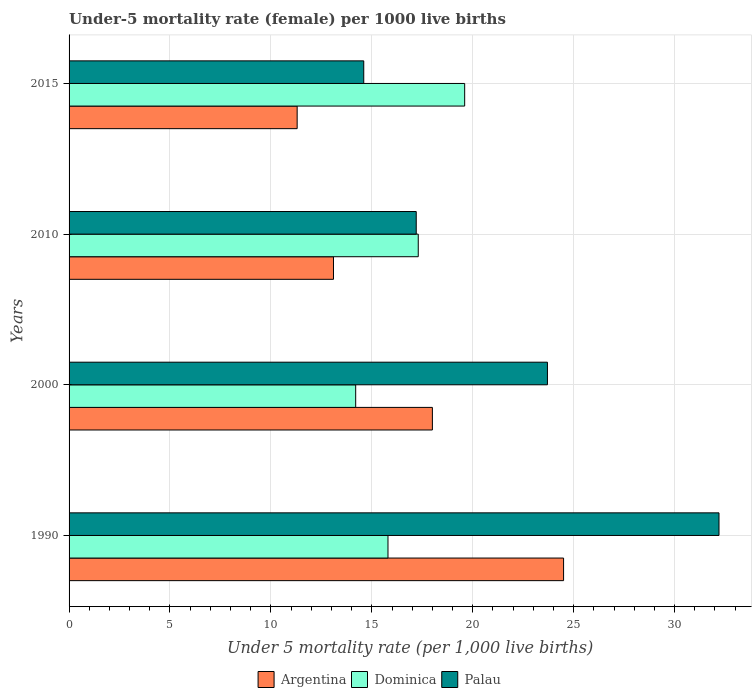How many different coloured bars are there?
Provide a short and direct response. 3. How many groups of bars are there?
Make the answer very short. 4. Are the number of bars on each tick of the Y-axis equal?
Ensure brevity in your answer.  Yes. How many bars are there on the 1st tick from the top?
Ensure brevity in your answer.  3. Across all years, what is the maximum under-five mortality rate in Palau?
Your response must be concise. 32.2. In which year was the under-five mortality rate in Palau maximum?
Make the answer very short. 1990. In which year was the under-five mortality rate in Argentina minimum?
Your answer should be very brief. 2015. What is the total under-five mortality rate in Palau in the graph?
Make the answer very short. 87.7. What is the difference between the under-five mortality rate in Dominica in 1990 and that in 2000?
Give a very brief answer. 1.6. What is the difference between the under-five mortality rate in Argentina in 1990 and the under-five mortality rate in Palau in 2010?
Give a very brief answer. 7.3. What is the average under-five mortality rate in Argentina per year?
Ensure brevity in your answer.  16.73. In the year 2000, what is the difference between the under-five mortality rate in Palau and under-five mortality rate in Argentina?
Provide a short and direct response. 5.7. What is the ratio of the under-five mortality rate in Argentina in 1990 to that in 2015?
Your answer should be compact. 2.17. What is the difference between the highest and the second highest under-five mortality rate in Dominica?
Offer a very short reply. 2.3. In how many years, is the under-five mortality rate in Argentina greater than the average under-five mortality rate in Argentina taken over all years?
Provide a succinct answer. 2. What does the 1st bar from the top in 2010 represents?
Make the answer very short. Palau. Is it the case that in every year, the sum of the under-five mortality rate in Palau and under-five mortality rate in Argentina is greater than the under-five mortality rate in Dominica?
Your answer should be compact. Yes. How many years are there in the graph?
Offer a terse response. 4. Where does the legend appear in the graph?
Give a very brief answer. Bottom center. What is the title of the graph?
Provide a succinct answer. Under-5 mortality rate (female) per 1000 live births. Does "Puerto Rico" appear as one of the legend labels in the graph?
Ensure brevity in your answer.  No. What is the label or title of the X-axis?
Your answer should be compact. Under 5 mortality rate (per 1,0 live births). What is the label or title of the Y-axis?
Your response must be concise. Years. What is the Under 5 mortality rate (per 1,000 live births) of Dominica in 1990?
Your response must be concise. 15.8. What is the Under 5 mortality rate (per 1,000 live births) in Palau in 1990?
Make the answer very short. 32.2. What is the Under 5 mortality rate (per 1,000 live births) of Argentina in 2000?
Keep it short and to the point. 18. What is the Under 5 mortality rate (per 1,000 live births) of Palau in 2000?
Provide a short and direct response. 23.7. What is the Under 5 mortality rate (per 1,000 live births) in Argentina in 2010?
Give a very brief answer. 13.1. What is the Under 5 mortality rate (per 1,000 live births) of Palau in 2010?
Offer a very short reply. 17.2. What is the Under 5 mortality rate (per 1,000 live births) of Dominica in 2015?
Provide a succinct answer. 19.6. What is the Under 5 mortality rate (per 1,000 live births) of Palau in 2015?
Give a very brief answer. 14.6. Across all years, what is the maximum Under 5 mortality rate (per 1,000 live births) in Argentina?
Make the answer very short. 24.5. Across all years, what is the maximum Under 5 mortality rate (per 1,000 live births) of Dominica?
Give a very brief answer. 19.6. Across all years, what is the maximum Under 5 mortality rate (per 1,000 live births) in Palau?
Your response must be concise. 32.2. Across all years, what is the minimum Under 5 mortality rate (per 1,000 live births) in Palau?
Give a very brief answer. 14.6. What is the total Under 5 mortality rate (per 1,000 live births) in Argentina in the graph?
Your answer should be very brief. 66.9. What is the total Under 5 mortality rate (per 1,000 live births) of Dominica in the graph?
Provide a succinct answer. 66.9. What is the total Under 5 mortality rate (per 1,000 live births) in Palau in the graph?
Your response must be concise. 87.7. What is the difference between the Under 5 mortality rate (per 1,000 live births) in Dominica in 1990 and that in 2000?
Ensure brevity in your answer.  1.6. What is the difference between the Under 5 mortality rate (per 1,000 live births) in Argentina in 1990 and that in 2010?
Offer a very short reply. 11.4. What is the difference between the Under 5 mortality rate (per 1,000 live births) of Dominica in 1990 and that in 2010?
Offer a very short reply. -1.5. What is the difference between the Under 5 mortality rate (per 1,000 live births) in Dominica in 2000 and that in 2010?
Provide a short and direct response. -3.1. What is the difference between the Under 5 mortality rate (per 1,000 live births) of Palau in 2000 and that in 2010?
Your response must be concise. 6.5. What is the difference between the Under 5 mortality rate (per 1,000 live births) of Argentina in 2000 and that in 2015?
Make the answer very short. 6.7. What is the difference between the Under 5 mortality rate (per 1,000 live births) in Palau in 2000 and that in 2015?
Offer a very short reply. 9.1. What is the difference between the Under 5 mortality rate (per 1,000 live births) in Argentina in 1990 and the Under 5 mortality rate (per 1,000 live births) in Dominica in 2000?
Make the answer very short. 10.3. What is the difference between the Under 5 mortality rate (per 1,000 live births) of Argentina in 1990 and the Under 5 mortality rate (per 1,000 live births) of Palau in 2000?
Ensure brevity in your answer.  0.8. What is the difference between the Under 5 mortality rate (per 1,000 live births) in Dominica in 1990 and the Under 5 mortality rate (per 1,000 live births) in Palau in 2000?
Ensure brevity in your answer.  -7.9. What is the difference between the Under 5 mortality rate (per 1,000 live births) in Argentina in 1990 and the Under 5 mortality rate (per 1,000 live births) in Dominica in 2010?
Your response must be concise. 7.2. What is the difference between the Under 5 mortality rate (per 1,000 live births) in Argentina in 1990 and the Under 5 mortality rate (per 1,000 live births) in Palau in 2010?
Provide a succinct answer. 7.3. What is the difference between the Under 5 mortality rate (per 1,000 live births) of Dominica in 1990 and the Under 5 mortality rate (per 1,000 live births) of Palau in 2010?
Provide a succinct answer. -1.4. What is the difference between the Under 5 mortality rate (per 1,000 live births) in Argentina in 1990 and the Under 5 mortality rate (per 1,000 live births) in Palau in 2015?
Your answer should be very brief. 9.9. What is the difference between the Under 5 mortality rate (per 1,000 live births) of Argentina in 2000 and the Under 5 mortality rate (per 1,000 live births) of Dominica in 2010?
Keep it short and to the point. 0.7. What is the difference between the Under 5 mortality rate (per 1,000 live births) in Argentina in 2000 and the Under 5 mortality rate (per 1,000 live births) in Dominica in 2015?
Provide a succinct answer. -1.6. What is the difference between the Under 5 mortality rate (per 1,000 live births) in Argentina in 2000 and the Under 5 mortality rate (per 1,000 live births) in Palau in 2015?
Ensure brevity in your answer.  3.4. What is the difference between the Under 5 mortality rate (per 1,000 live births) of Dominica in 2000 and the Under 5 mortality rate (per 1,000 live births) of Palau in 2015?
Give a very brief answer. -0.4. What is the difference between the Under 5 mortality rate (per 1,000 live births) in Argentina in 2010 and the Under 5 mortality rate (per 1,000 live births) in Dominica in 2015?
Your response must be concise. -6.5. What is the difference between the Under 5 mortality rate (per 1,000 live births) in Argentina in 2010 and the Under 5 mortality rate (per 1,000 live births) in Palau in 2015?
Offer a terse response. -1.5. What is the difference between the Under 5 mortality rate (per 1,000 live births) in Dominica in 2010 and the Under 5 mortality rate (per 1,000 live births) in Palau in 2015?
Your response must be concise. 2.7. What is the average Under 5 mortality rate (per 1,000 live births) in Argentina per year?
Provide a succinct answer. 16.73. What is the average Under 5 mortality rate (per 1,000 live births) of Dominica per year?
Ensure brevity in your answer.  16.73. What is the average Under 5 mortality rate (per 1,000 live births) of Palau per year?
Your response must be concise. 21.93. In the year 1990, what is the difference between the Under 5 mortality rate (per 1,000 live births) of Argentina and Under 5 mortality rate (per 1,000 live births) of Dominica?
Offer a very short reply. 8.7. In the year 1990, what is the difference between the Under 5 mortality rate (per 1,000 live births) in Argentina and Under 5 mortality rate (per 1,000 live births) in Palau?
Offer a terse response. -7.7. In the year 1990, what is the difference between the Under 5 mortality rate (per 1,000 live births) in Dominica and Under 5 mortality rate (per 1,000 live births) in Palau?
Provide a succinct answer. -16.4. In the year 2000, what is the difference between the Under 5 mortality rate (per 1,000 live births) in Dominica and Under 5 mortality rate (per 1,000 live births) in Palau?
Your response must be concise. -9.5. In the year 2010, what is the difference between the Under 5 mortality rate (per 1,000 live births) of Dominica and Under 5 mortality rate (per 1,000 live births) of Palau?
Your answer should be compact. 0.1. What is the ratio of the Under 5 mortality rate (per 1,000 live births) in Argentina in 1990 to that in 2000?
Keep it short and to the point. 1.36. What is the ratio of the Under 5 mortality rate (per 1,000 live births) in Dominica in 1990 to that in 2000?
Your answer should be very brief. 1.11. What is the ratio of the Under 5 mortality rate (per 1,000 live births) in Palau in 1990 to that in 2000?
Provide a short and direct response. 1.36. What is the ratio of the Under 5 mortality rate (per 1,000 live births) in Argentina in 1990 to that in 2010?
Give a very brief answer. 1.87. What is the ratio of the Under 5 mortality rate (per 1,000 live births) of Dominica in 1990 to that in 2010?
Ensure brevity in your answer.  0.91. What is the ratio of the Under 5 mortality rate (per 1,000 live births) in Palau in 1990 to that in 2010?
Your response must be concise. 1.87. What is the ratio of the Under 5 mortality rate (per 1,000 live births) in Argentina in 1990 to that in 2015?
Your answer should be compact. 2.17. What is the ratio of the Under 5 mortality rate (per 1,000 live births) in Dominica in 1990 to that in 2015?
Provide a short and direct response. 0.81. What is the ratio of the Under 5 mortality rate (per 1,000 live births) in Palau in 1990 to that in 2015?
Provide a succinct answer. 2.21. What is the ratio of the Under 5 mortality rate (per 1,000 live births) of Argentina in 2000 to that in 2010?
Give a very brief answer. 1.37. What is the ratio of the Under 5 mortality rate (per 1,000 live births) of Dominica in 2000 to that in 2010?
Give a very brief answer. 0.82. What is the ratio of the Under 5 mortality rate (per 1,000 live births) in Palau in 2000 to that in 2010?
Your answer should be compact. 1.38. What is the ratio of the Under 5 mortality rate (per 1,000 live births) of Argentina in 2000 to that in 2015?
Your answer should be very brief. 1.59. What is the ratio of the Under 5 mortality rate (per 1,000 live births) in Dominica in 2000 to that in 2015?
Offer a very short reply. 0.72. What is the ratio of the Under 5 mortality rate (per 1,000 live births) in Palau in 2000 to that in 2015?
Provide a short and direct response. 1.62. What is the ratio of the Under 5 mortality rate (per 1,000 live births) of Argentina in 2010 to that in 2015?
Make the answer very short. 1.16. What is the ratio of the Under 5 mortality rate (per 1,000 live births) in Dominica in 2010 to that in 2015?
Provide a succinct answer. 0.88. What is the ratio of the Under 5 mortality rate (per 1,000 live births) in Palau in 2010 to that in 2015?
Provide a short and direct response. 1.18. What is the difference between the highest and the second highest Under 5 mortality rate (per 1,000 live births) in Argentina?
Make the answer very short. 6.5. What is the difference between the highest and the second highest Under 5 mortality rate (per 1,000 live births) of Dominica?
Offer a terse response. 2.3. What is the difference between the highest and the lowest Under 5 mortality rate (per 1,000 live births) of Argentina?
Give a very brief answer. 13.2. What is the difference between the highest and the lowest Under 5 mortality rate (per 1,000 live births) in Dominica?
Offer a very short reply. 5.4. What is the difference between the highest and the lowest Under 5 mortality rate (per 1,000 live births) of Palau?
Your response must be concise. 17.6. 